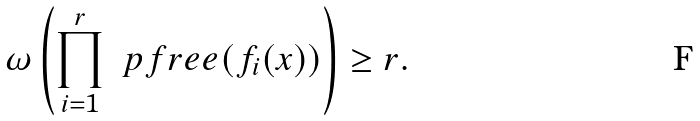<formula> <loc_0><loc_0><loc_500><loc_500>\omega \left ( \prod _ { i = 1 } ^ { r } \ p f r e e ( f _ { i } ( x ) ) \right ) \geq r .</formula> 